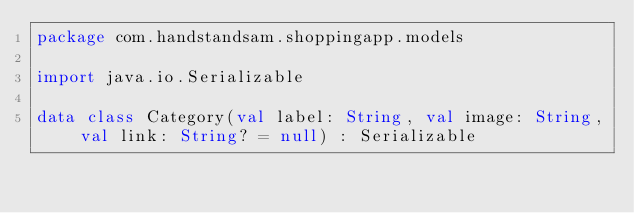Convert code to text. <code><loc_0><loc_0><loc_500><loc_500><_Kotlin_>package com.handstandsam.shoppingapp.models

import java.io.Serializable

data class Category(val label: String, val image: String, val link: String? = null) : Serializable
</code> 